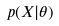Convert formula to latex. <formula><loc_0><loc_0><loc_500><loc_500>p ( X | \theta )</formula> 